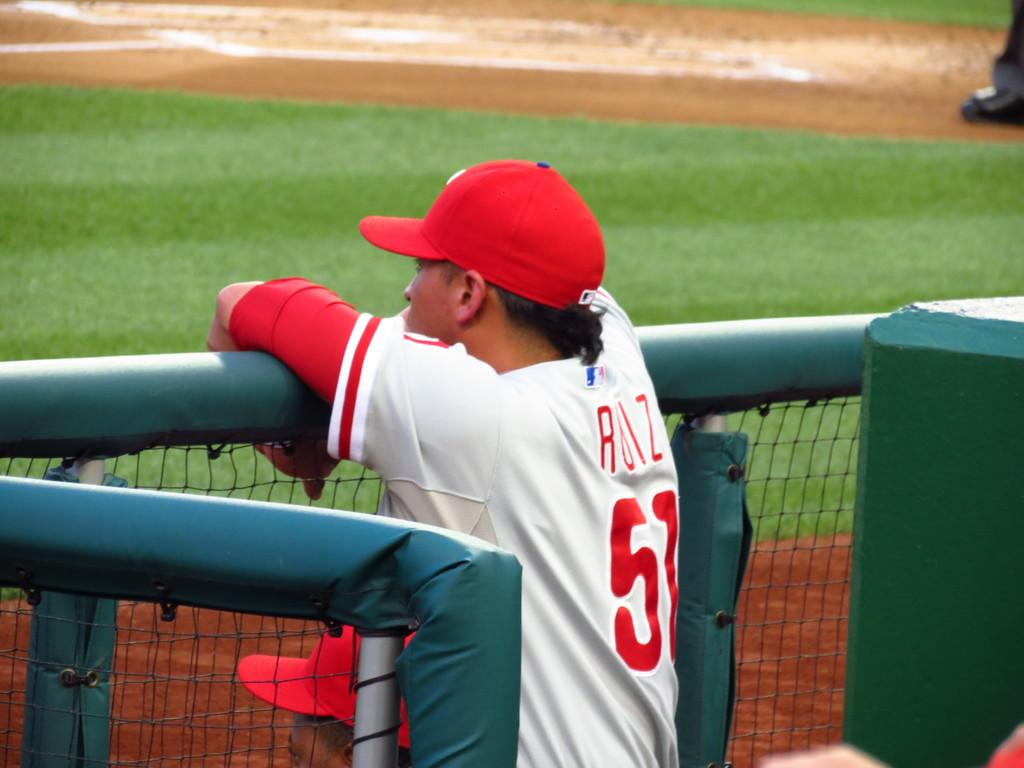<image>
Share a concise interpretation of the image provided. A baseball player who's name starts with an R, watching the basebell field from the dugout. 